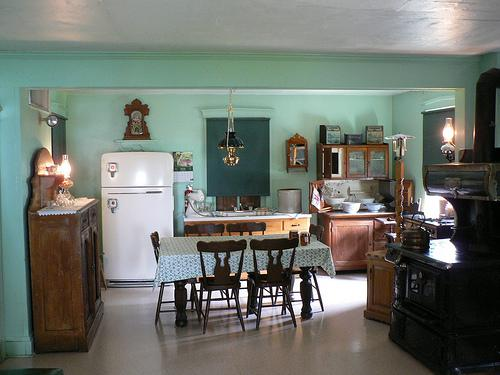Question: what is green?
Choices:
A. The grass.
B. Girl's dress.
C. The wall.
D. Car.
Answer with the letter. Answer: C Question: how many chairs are at the table?
Choices:
A. Four.
B. Five.
C. Six.
D. Three.
Answer with the letter. Answer: C Question: what is brown?
Choices:
A. Chairs.
B. Teddy bear.
C. Grass.
D. House.
Answer with the letter. Answer: A Question: what is on the table?
Choices:
A. Food.
B. Fruit bowl.
C. Candle.
D. Tablecloth.
Answer with the letter. Answer: D Question: what is a white?
Choices:
A. House.
B. A fridge.
C. Car.
D. Wedding gown.
Answer with the letter. Answer: B Question: where is a light hanging from?
Choices:
A. From the ceiling.
B. Pole.
C. Tree.
D. Fixture.
Answer with the letter. Answer: A Question: where are reflections?
Choices:
A. In water.
B. On the floor.
C. In window.
D. In mirror.
Answer with the letter. Answer: B 